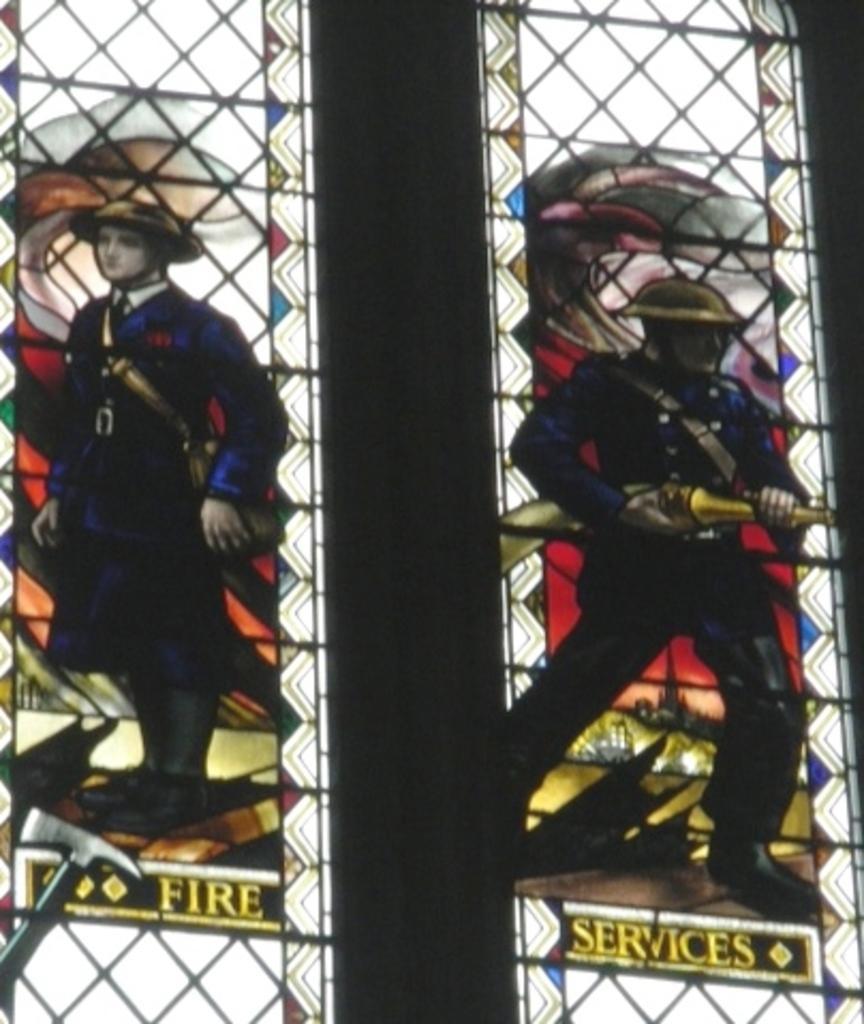In one or two sentences, can you explain what this image depicts? In this picture I can see words and photos of two persons on the glasses of the windows, and there are iron grilles. 